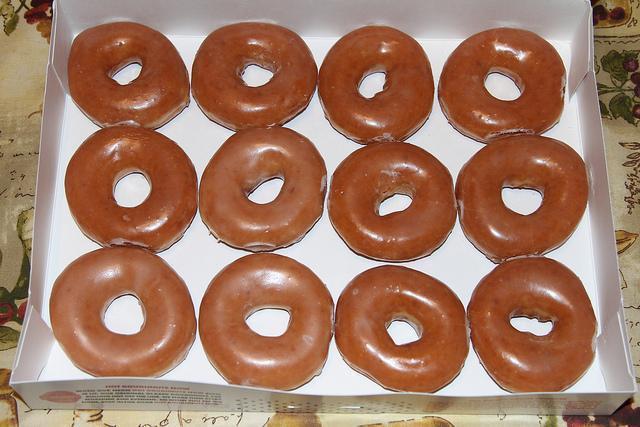What type of coating is found on the paper below the donuts?
Select the accurate response from the four choices given to answer the question.
Options: Food coloring, glue, wax, ash. Wax. 